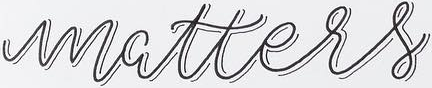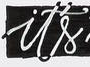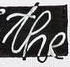What text appears in these images from left to right, separated by a semicolon? matters; it's; the 